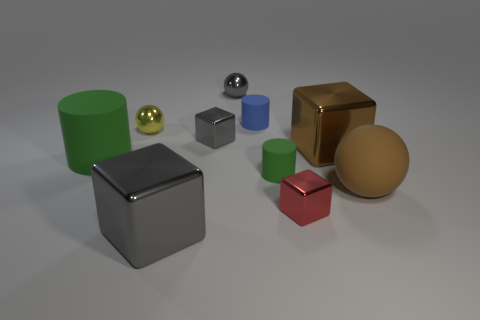How many objects in the photo have circular bases? There are three objects with circular bases in this image: two cylinders and one sphere. 